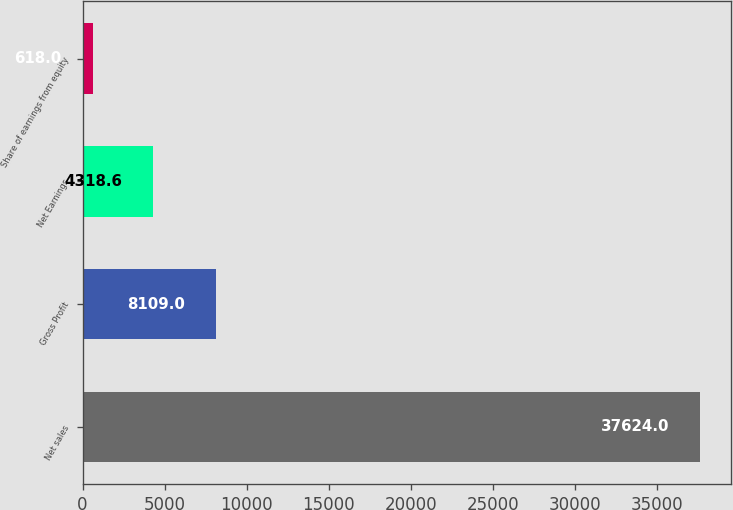Convert chart. <chart><loc_0><loc_0><loc_500><loc_500><bar_chart><fcel>Net sales<fcel>Gross Profit<fcel>Net Earnings<fcel>Share of earnings from equity<nl><fcel>37624<fcel>8109<fcel>4318.6<fcel>618<nl></chart> 